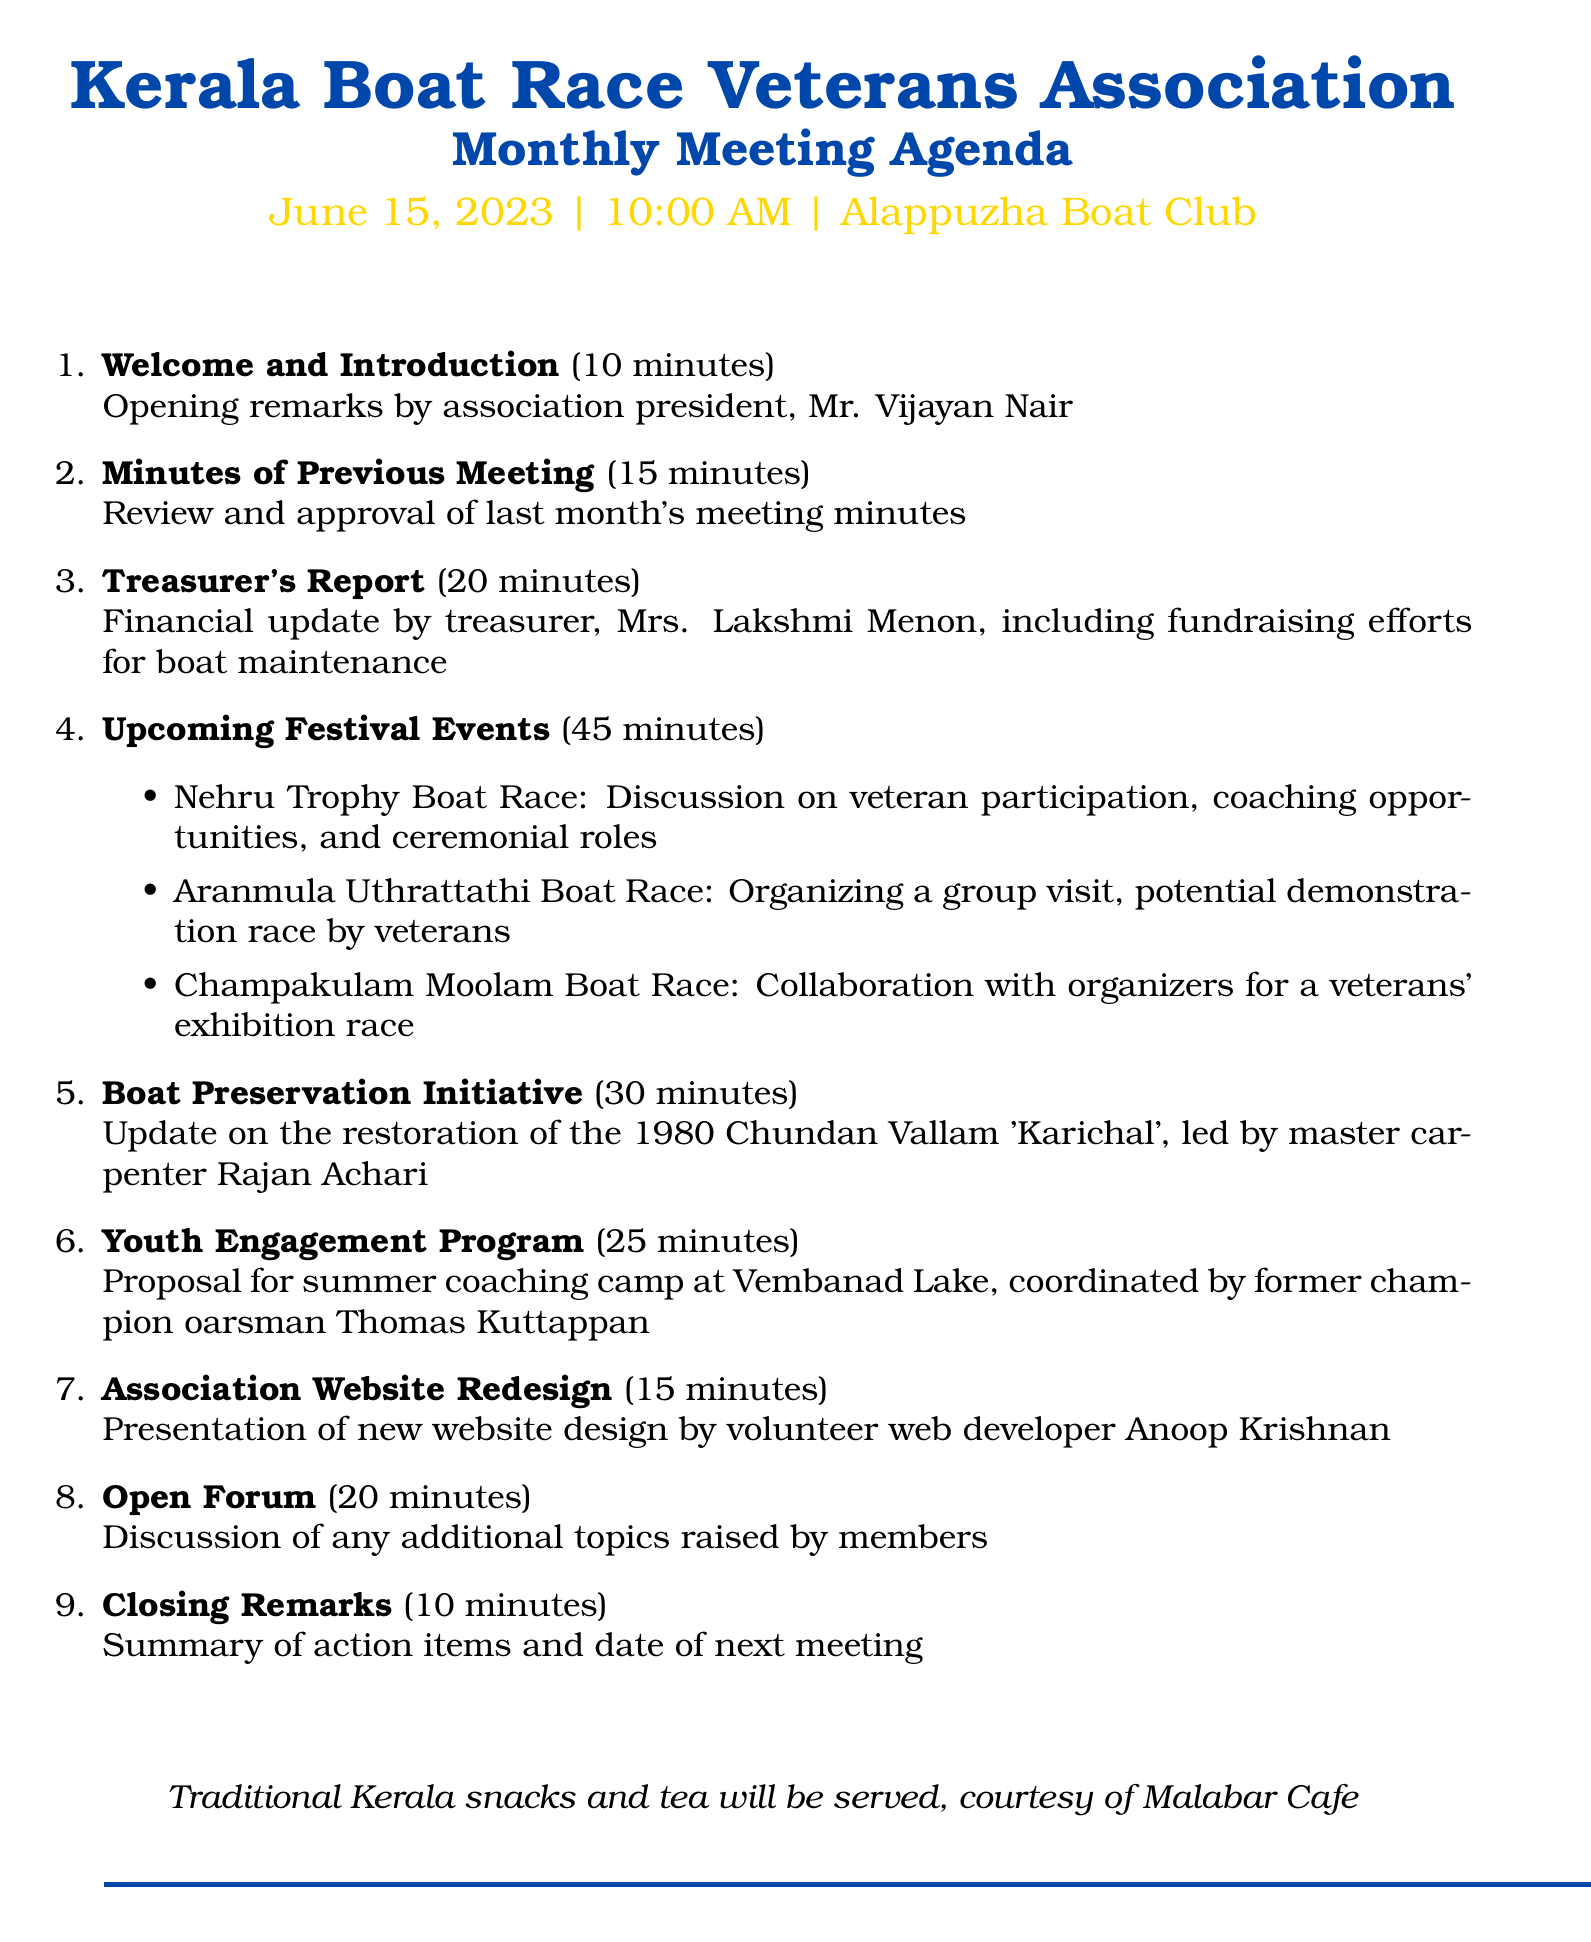What is the name of the association? The document states that the association is called the Kerala Boat Race Veterans Association.
Answer: Kerala Boat Race Veterans Association Who is the treasurer? According to the document, the treasurer is Mrs. Lakshmi Menon.
Answer: Mrs. Lakshmi Menon What is the location of the meeting? The document specifies that the meeting will be held at Alappuzha Boat Club.
Answer: Alappuzha Boat Club How long is the discussion on upcoming festival events? The document indicates that the discussion on upcoming festival events will last for 45 minutes.
Answer: 45 minutes What is one of the festival events discussed? The document includes the Nehru Trophy Boat Race as one of the festival events discussed.
Answer: Nehru Trophy Boat Race What is the duration allocated for the Youth Engagement Program? The document states that the Youth Engagement Program will take 25 minutes.
Answer: 25 minutes What will be served during the meeting? The document mentions that traditional Kerala snacks and tea will be served.
Answer: Traditional Kerala snacks and tea Who will lead the restoration update of the Chundan Vallam? The document notes that master carpenter Rajan Achari will lead the restoration update.
Answer: Rajan Achari What is the date of the next meeting? The document states that the date of the next meeting will be summarized in the closing remarks, but it does not specify the exact date.
Answer: Not specified 